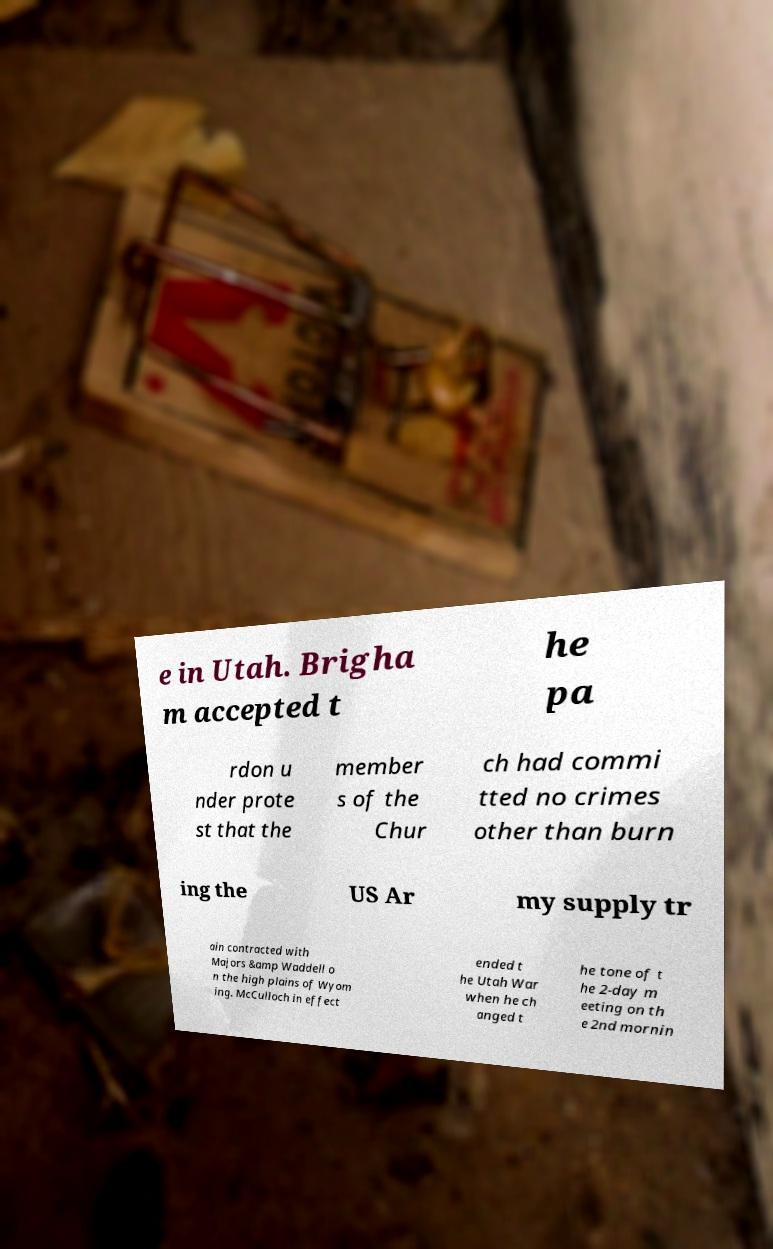Could you assist in decoding the text presented in this image and type it out clearly? e in Utah. Brigha m accepted t he pa rdon u nder prote st that the member s of the Chur ch had commi tted no crimes other than burn ing the US Ar my supply tr ain contracted with Majors &amp Waddell o n the high plains of Wyom ing. McCulloch in effect ended t he Utah War when he ch anged t he tone of t he 2-day m eeting on th e 2nd mornin 